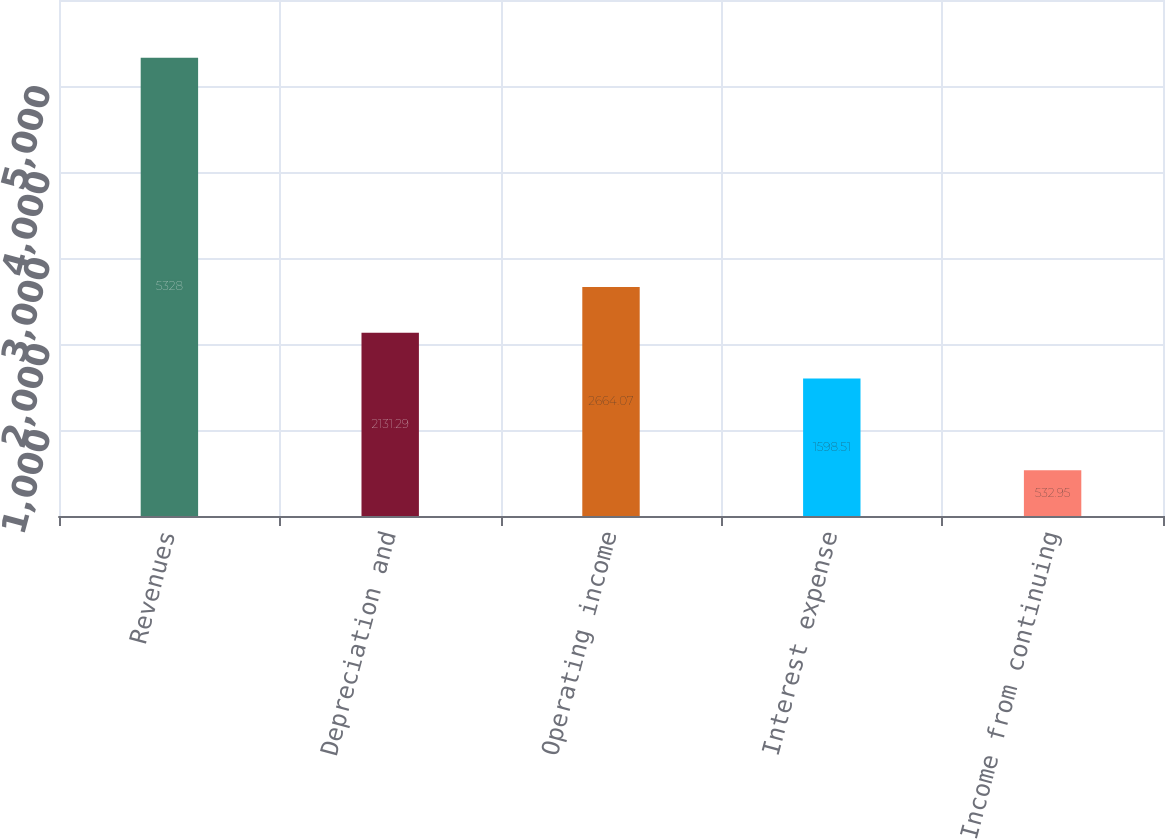Convert chart to OTSL. <chart><loc_0><loc_0><loc_500><loc_500><bar_chart><fcel>Revenues<fcel>Depreciation and<fcel>Operating income<fcel>Interest expense<fcel>Income from continuing<nl><fcel>5328<fcel>2131.29<fcel>2664.07<fcel>1598.51<fcel>532.95<nl></chart> 